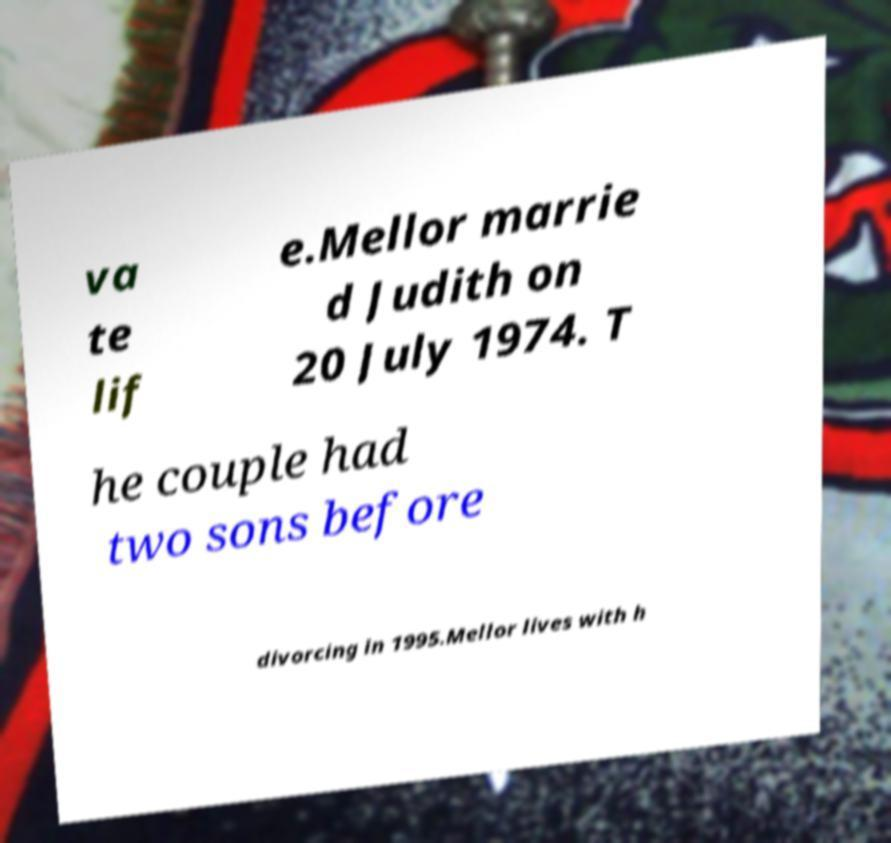Could you assist in decoding the text presented in this image and type it out clearly? va te lif e.Mellor marrie d Judith on 20 July 1974. T he couple had two sons before divorcing in 1995.Mellor lives with h 